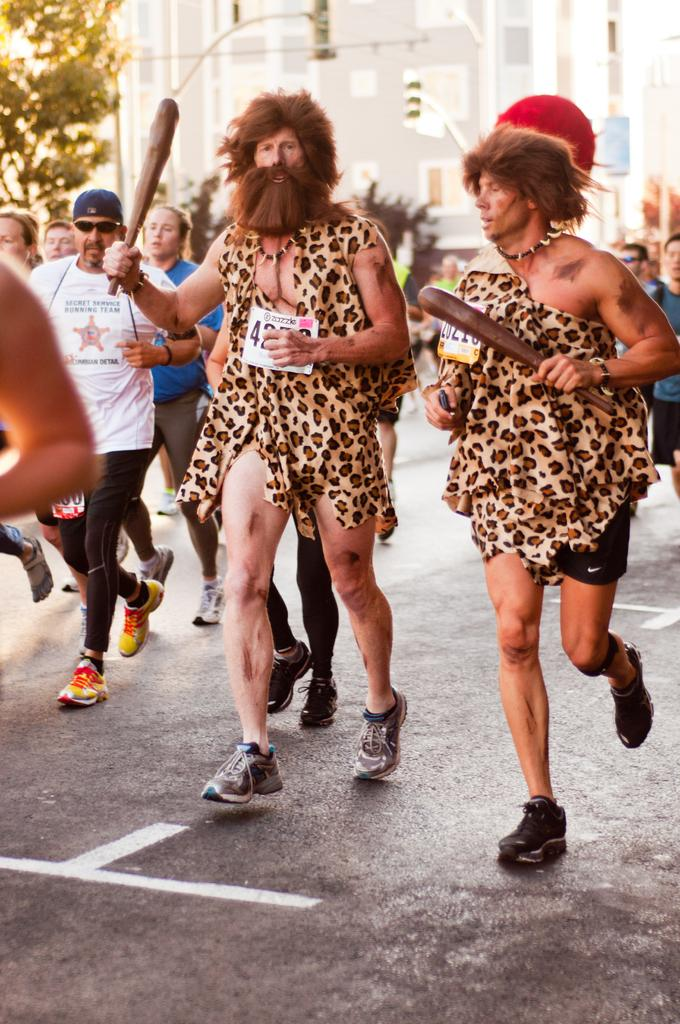How many people are in the image? There is a group of people in the image. What are some of the people doing in the image? Some people are running on the road. What can be seen in the background of the image? There are trees and a building in the background of the image. Where is the butter stored in the image? There is no butter present in the image. What type of garden can be seen in the background of the image? There is no garden visible in the image; only trees and a building are present in the background. 